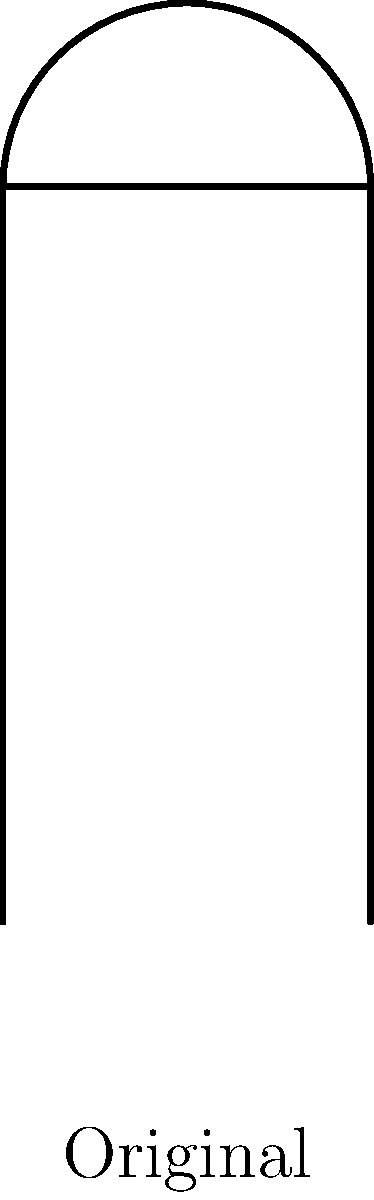In a music biography about a famous singer, the author uses microphone icons to represent different volume levels. If the original microphone icon represents a normal speaking volume, which scaled version (A or B) would best represent the singer's powerful high notes, and what is the scale factor used for that transformation? To determine which scaled version best represents the singer's powerful high notes and its scale factor, let's analyze the transformations:

1. The original microphone icon represents normal speaking volume.
2. We have two scaled versions: A and B.
3. To represent powerful high notes, we need the larger scale factor.

Let's calculate the scale factors:

For A:
- The width of A is 1.5 times the original.
- The height of A is also 1.5 times the original.
Therefore, A is scaled by a factor of 1.5.

For B:
- The width of B is 2 times the original.
- The height of B is also 2 times the original.
Therefore, B is scaled by a factor of 2.

Since 2 > 1.5, version B has the larger scale factor and would best represent the singer's powerful high notes.

The scale factor used for B is 2, which means it has been enlarged to twice its original size in both dimensions.
Answer: B, scale factor 2 